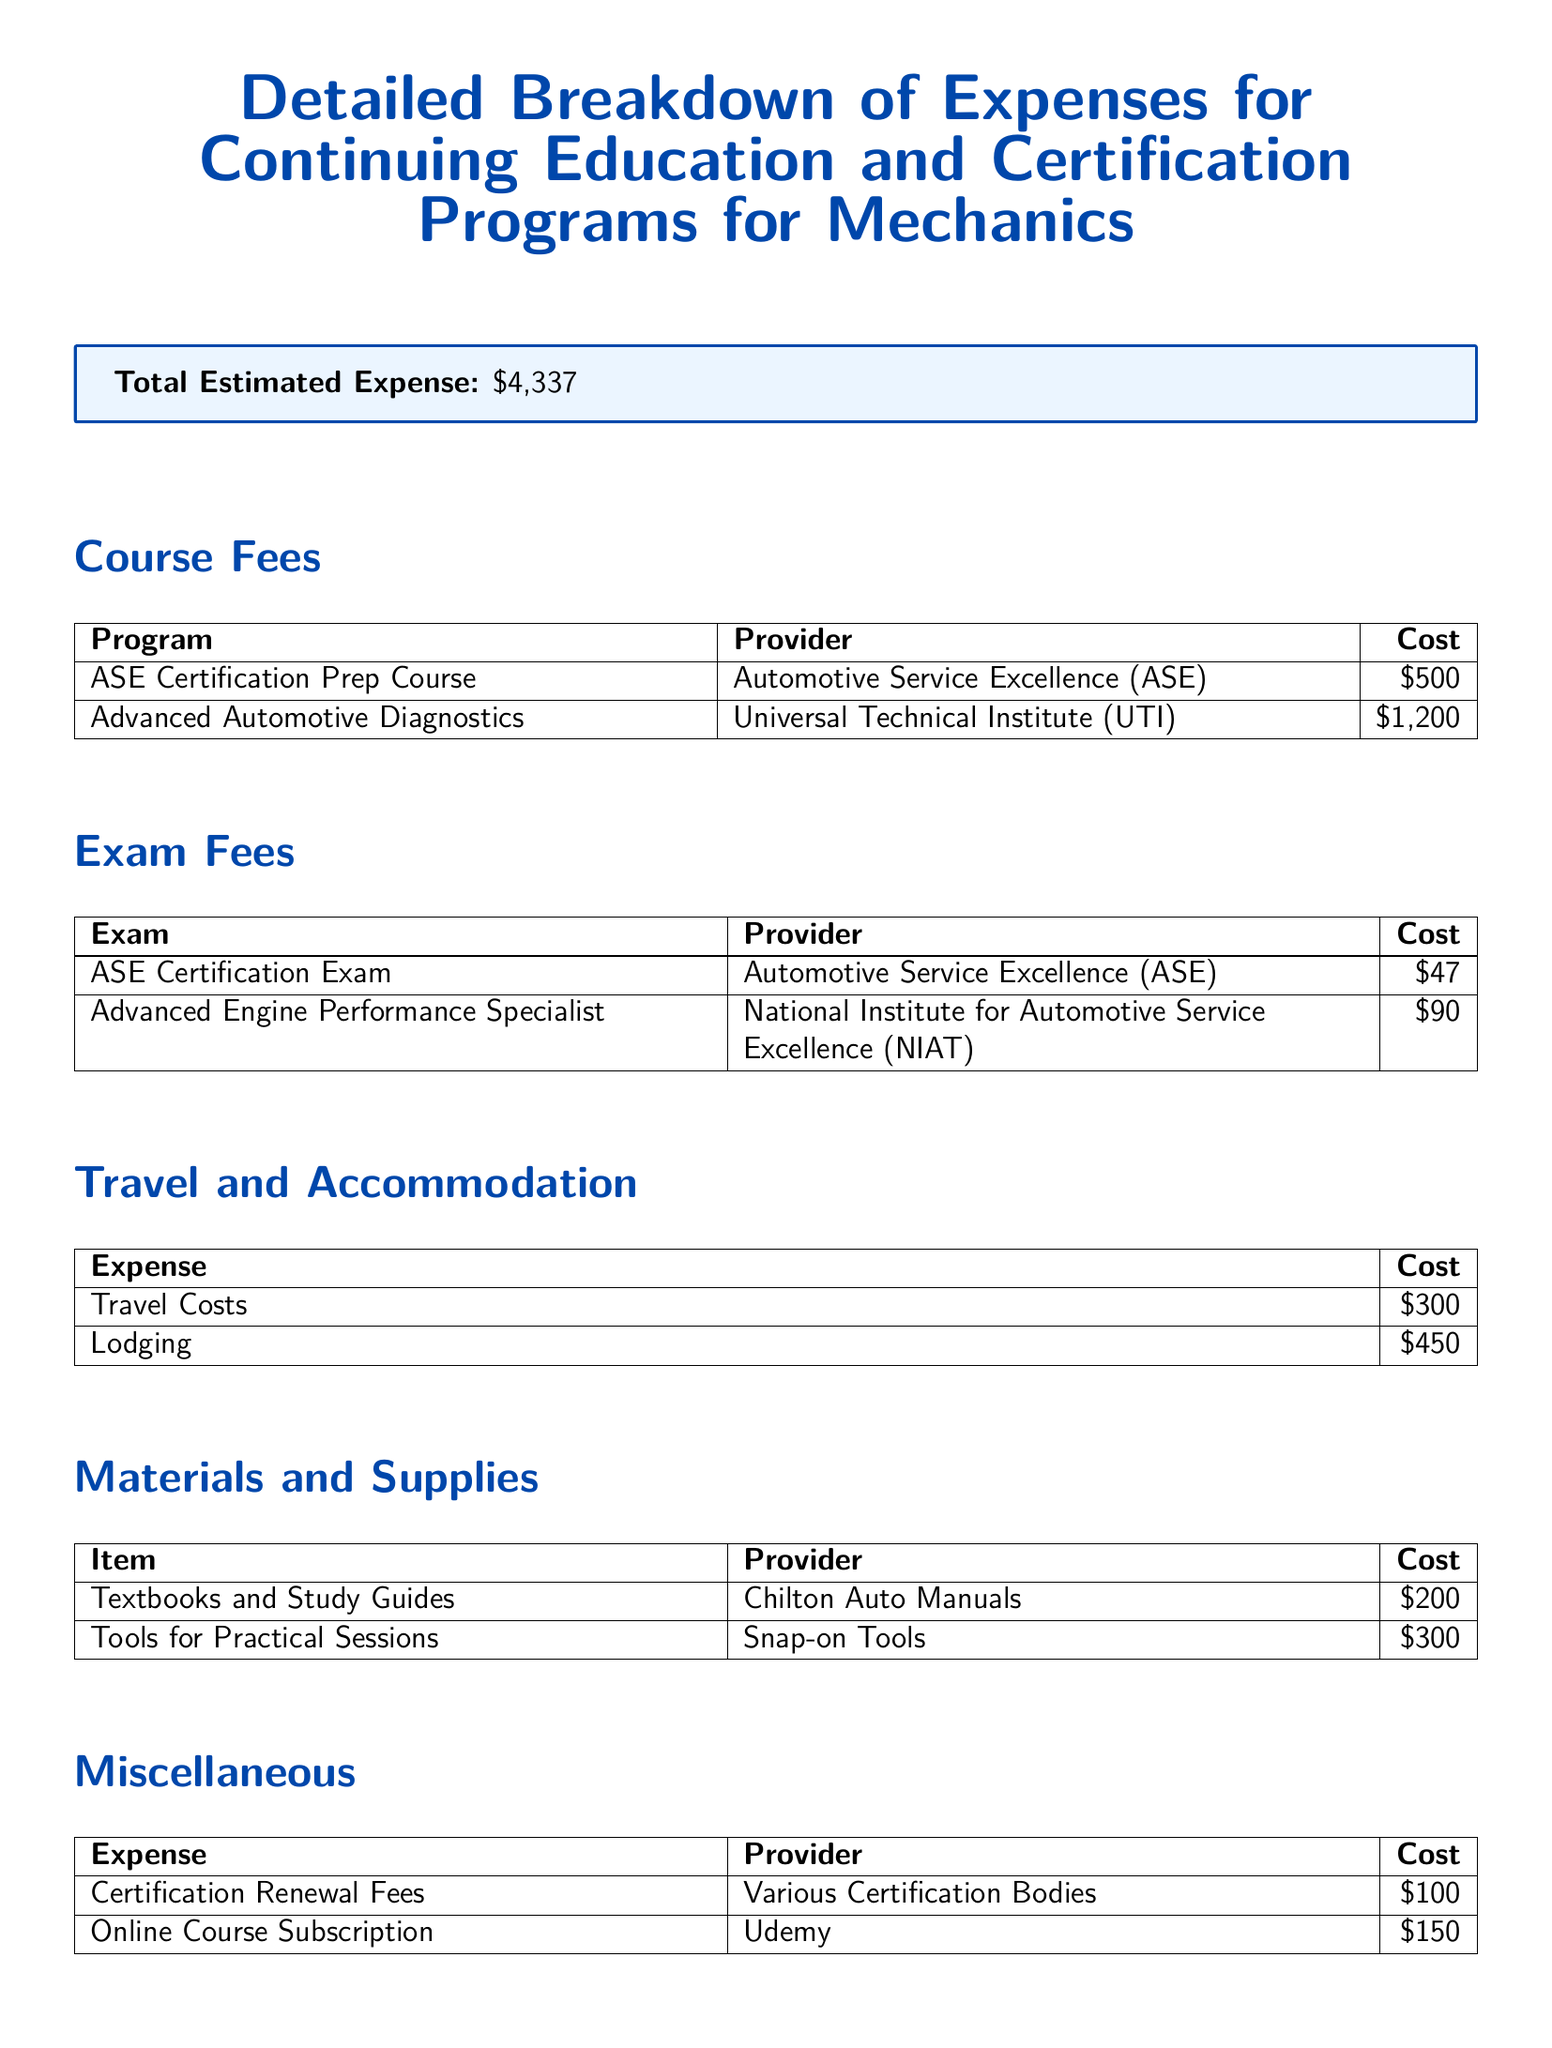What is the total estimated expense? The total estimated expense is provided in a highlighted box in the document.
Answer: $4,337 What is the cost of the ASE Certification Prep Course? The cost of the ASE Certification Prep Course is listed under Course Fees in the document.
Answer: $500 How much is the lodging expense? The lodging expense is detailed under Travel and Accommodation section in the document.
Answer: $450 Which provider offers the Advanced Automotive Diagnostics program? The provider for the Advanced Automotive Diagnostics program is listed in the Course Fees table.
Answer: Universal Technical Institute (UTI) What is the cost of tools for practical sessions? The cost of tools for practical sessions is mentioned under Materials and Supplies in the document.
Answer: $300 How many dollar amounts are detailed in the Exam Fees section? The number of dollar amounts listed corresponds to the number of exams shown in the Exam Fees table.
Answer: 2 What type of item is listed under Materials and Supplies? The type of items listed includes textbooks and tools, indicating the focus on educational materials and supplies.
Answer: Textbooks and Study Guides What is the cost for the Online Course Subscription? The cost for the Online Course Subscription is listed under the Miscellaneous section in the document.
Answer: $150 